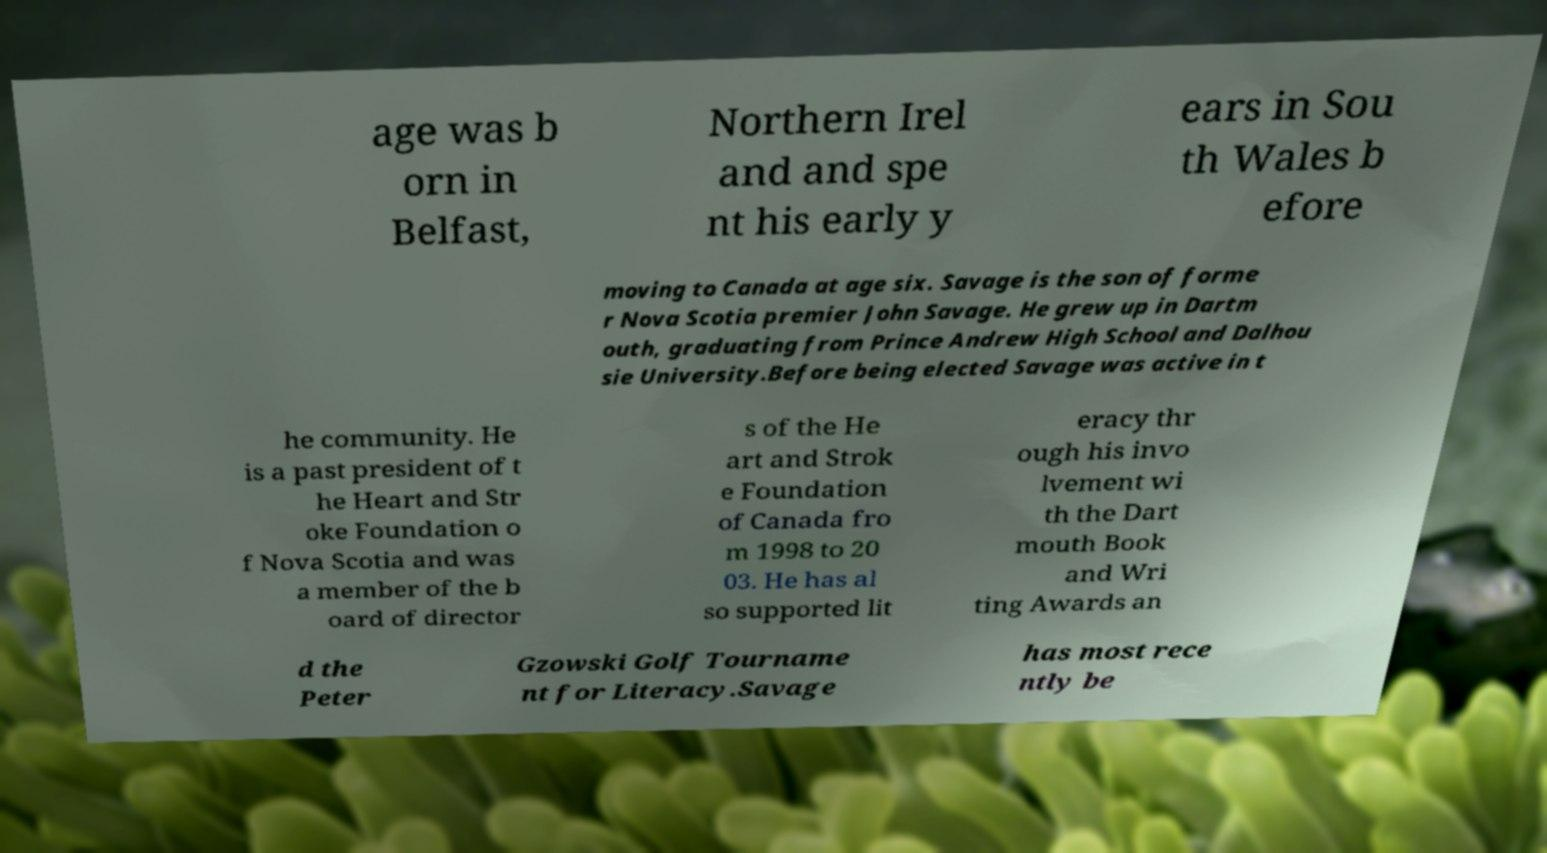Please read and relay the text visible in this image. What does it say? age was b orn in Belfast, Northern Irel and and spe nt his early y ears in Sou th Wales b efore moving to Canada at age six. Savage is the son of forme r Nova Scotia premier John Savage. He grew up in Dartm outh, graduating from Prince Andrew High School and Dalhou sie University.Before being elected Savage was active in t he community. He is a past president of t he Heart and Str oke Foundation o f Nova Scotia and was a member of the b oard of director s of the He art and Strok e Foundation of Canada fro m 1998 to 20 03. He has al so supported lit eracy thr ough his invo lvement wi th the Dart mouth Book and Wri ting Awards an d the Peter Gzowski Golf Tourname nt for Literacy.Savage has most rece ntly be 